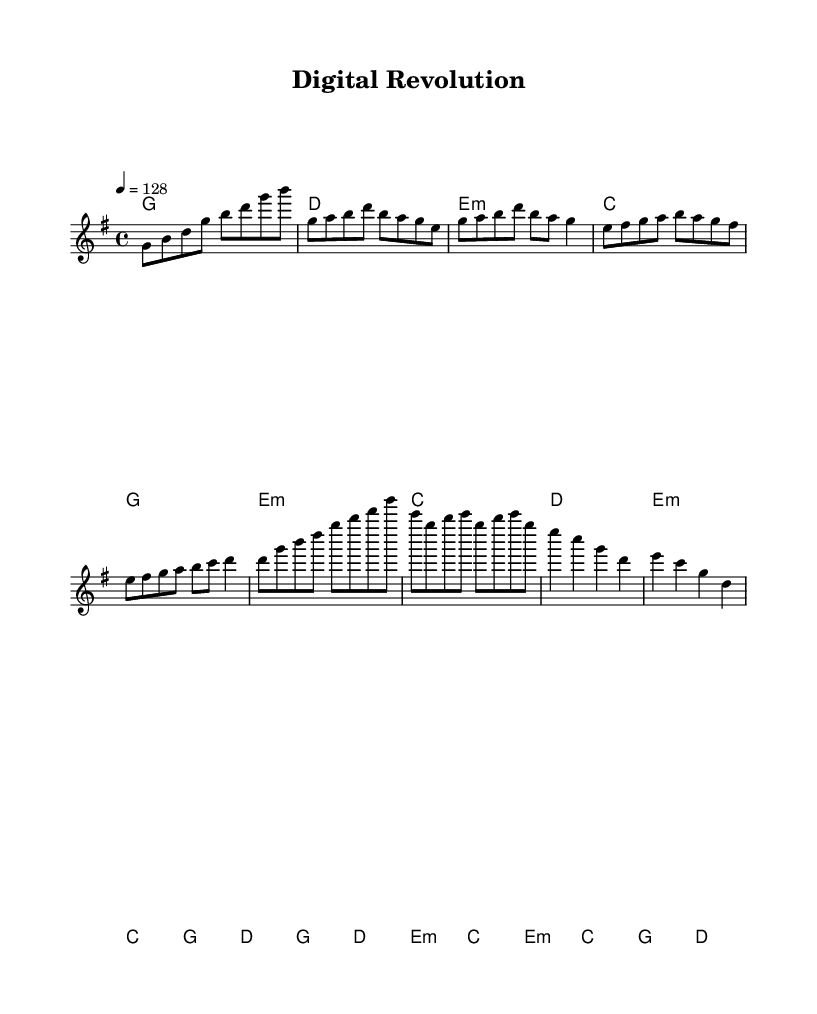What is the key signature of this music? The key signature is G major, which has one sharp (F#).
Answer: G major What is the time signature of this music? The time signature is 4/4, indicating four beats per measure.
Answer: 4/4 What is the tempo marking for this piece? The tempo marking indicates a speed of 128 beats per minute.
Answer: 128 How many measures are in the chorus section? The chorus consists of 4 measures, as seen in the music notation.
Answer: 4 What type of chords are primarily used in the pre-chorus section? The pre-chorus features a combination of major and minor chords, specifically E minor, C, G, and D.
Answer: Major and minor chords What unique lyrical theme is suggested by the title "Digital Revolution"? The title suggests a focus on technological advancements and innovation, a common theme in K-Pop lyrics.
Answer: Technology and innovation Which section of the music has the highest melodic note? The highest note in the melody is B, found in the pre-chorus and chorus sections.
Answer: B 